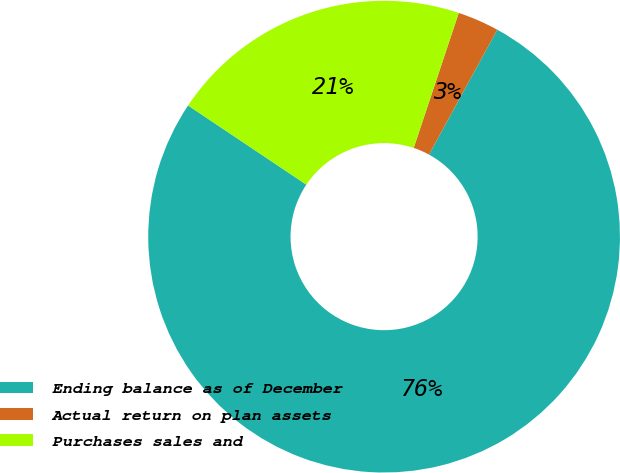Convert chart to OTSL. <chart><loc_0><loc_0><loc_500><loc_500><pie_chart><fcel>Ending balance as of December<fcel>Actual return on plan assets<fcel>Purchases sales and<nl><fcel>76.42%<fcel>2.84%<fcel>20.74%<nl></chart> 